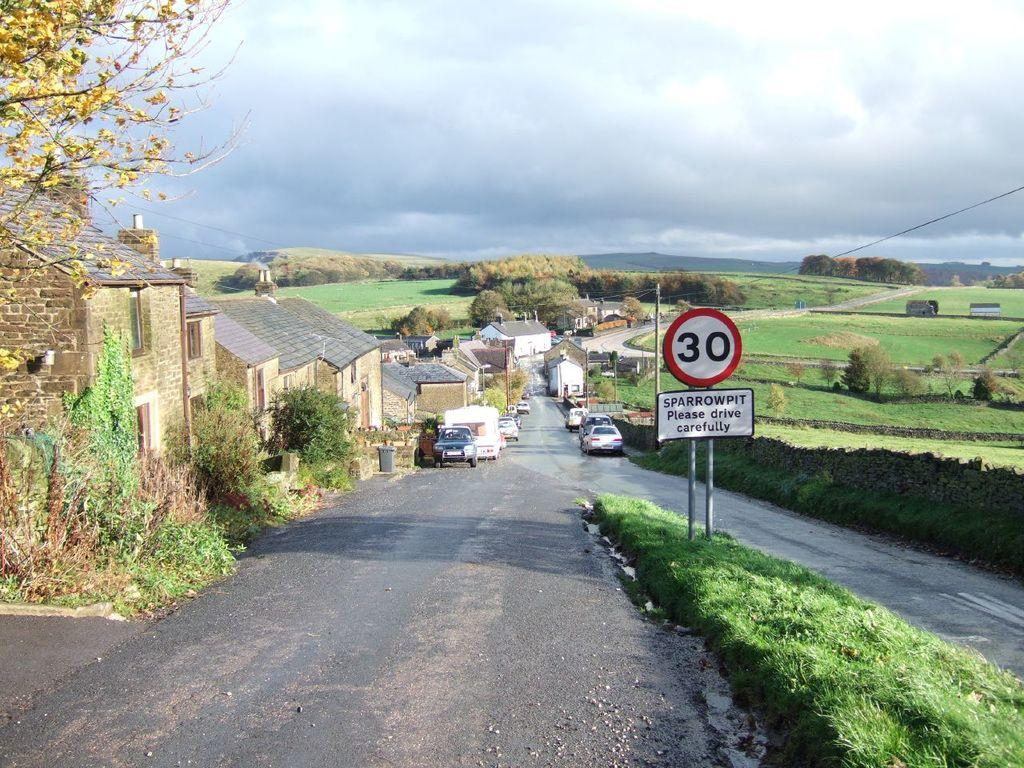Provide a one-sentence caption for the provided image. Cars and small buildings line a road in a countryside setting, and a posted street sign announces a 30 speed limit, and "SPARROWPIT" and cautions drivers to, "please drive carefully.". 